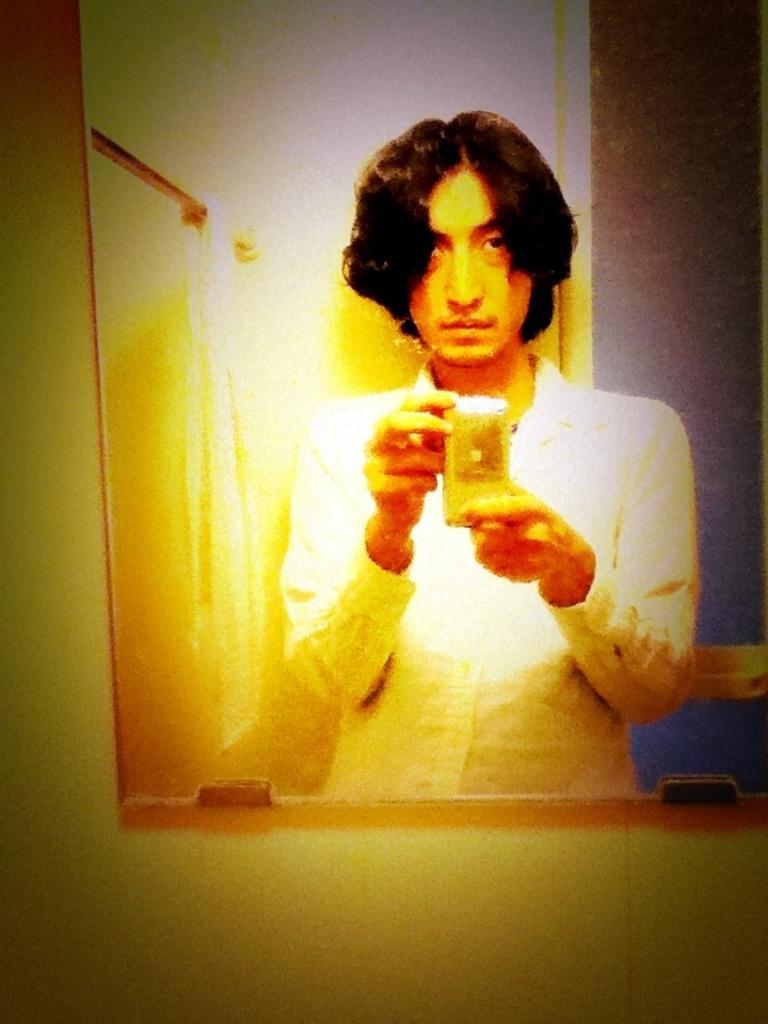Could you give a brief overview of what you see in this image? In this picture I can see there is a picture of a man standing and he is clicking a picture, there is a mirror in front of him. 